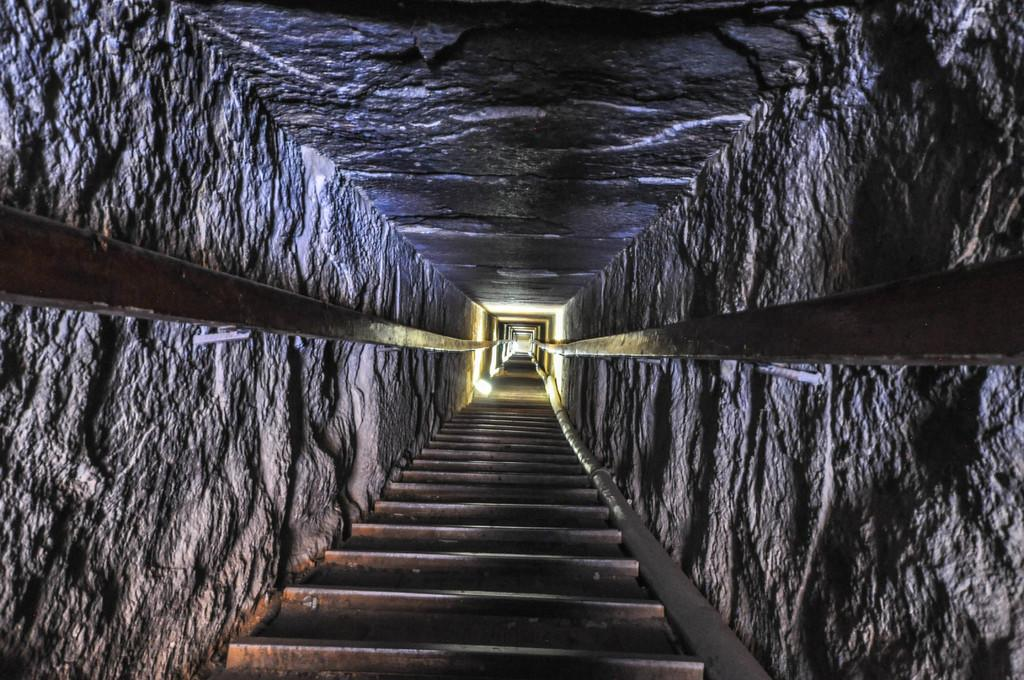What is the main feature of the image? There is a tunnel in the image. What can be seen at the bottom of the tunnel? There are iron bars at the bottom of the tunnel. What is present on the left side of the tunnel? There are poles attached to stones on the left side of the tunnel. What is present on the right side of the tunnel? There are poles attached to stones on the right side of the tunnel. How do the giants control the tunnel in the image? There are no giants present in the image, and therefore they cannot control the tunnel. Is there any indication that the tunnel is used for sleeping in the image? There is no indication that the tunnel is used for sleeping in the image. 